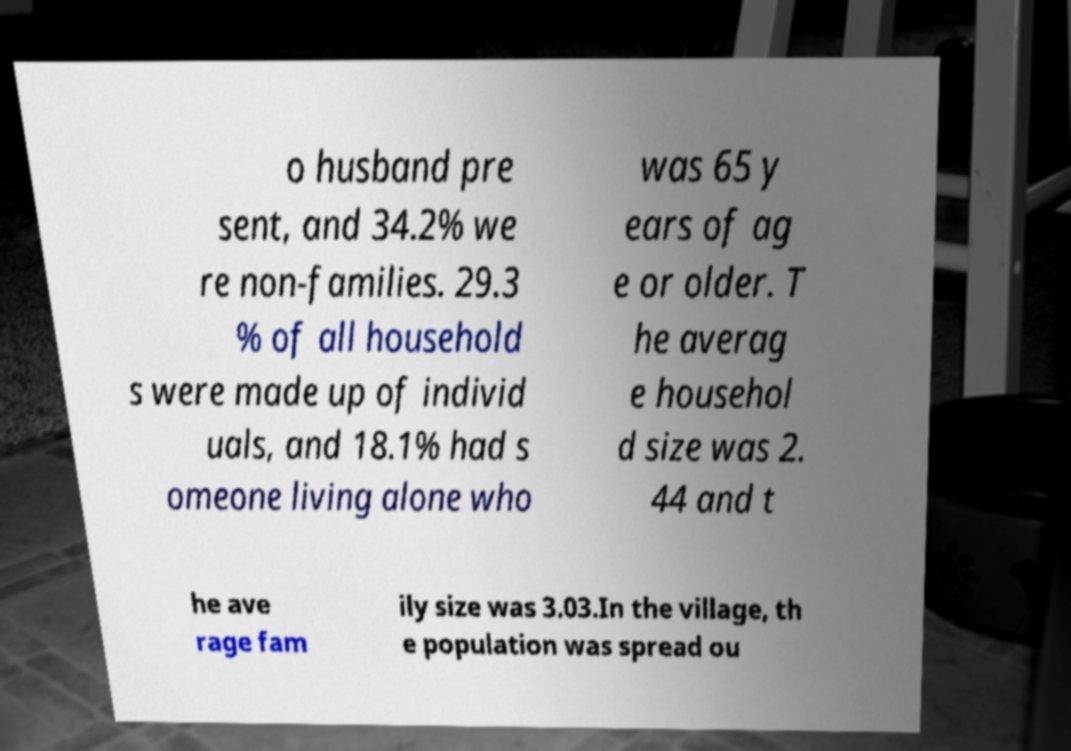What messages or text are displayed in this image? I need them in a readable, typed format. o husband pre sent, and 34.2% we re non-families. 29.3 % of all household s were made up of individ uals, and 18.1% had s omeone living alone who was 65 y ears of ag e or older. T he averag e househol d size was 2. 44 and t he ave rage fam ily size was 3.03.In the village, th e population was spread ou 